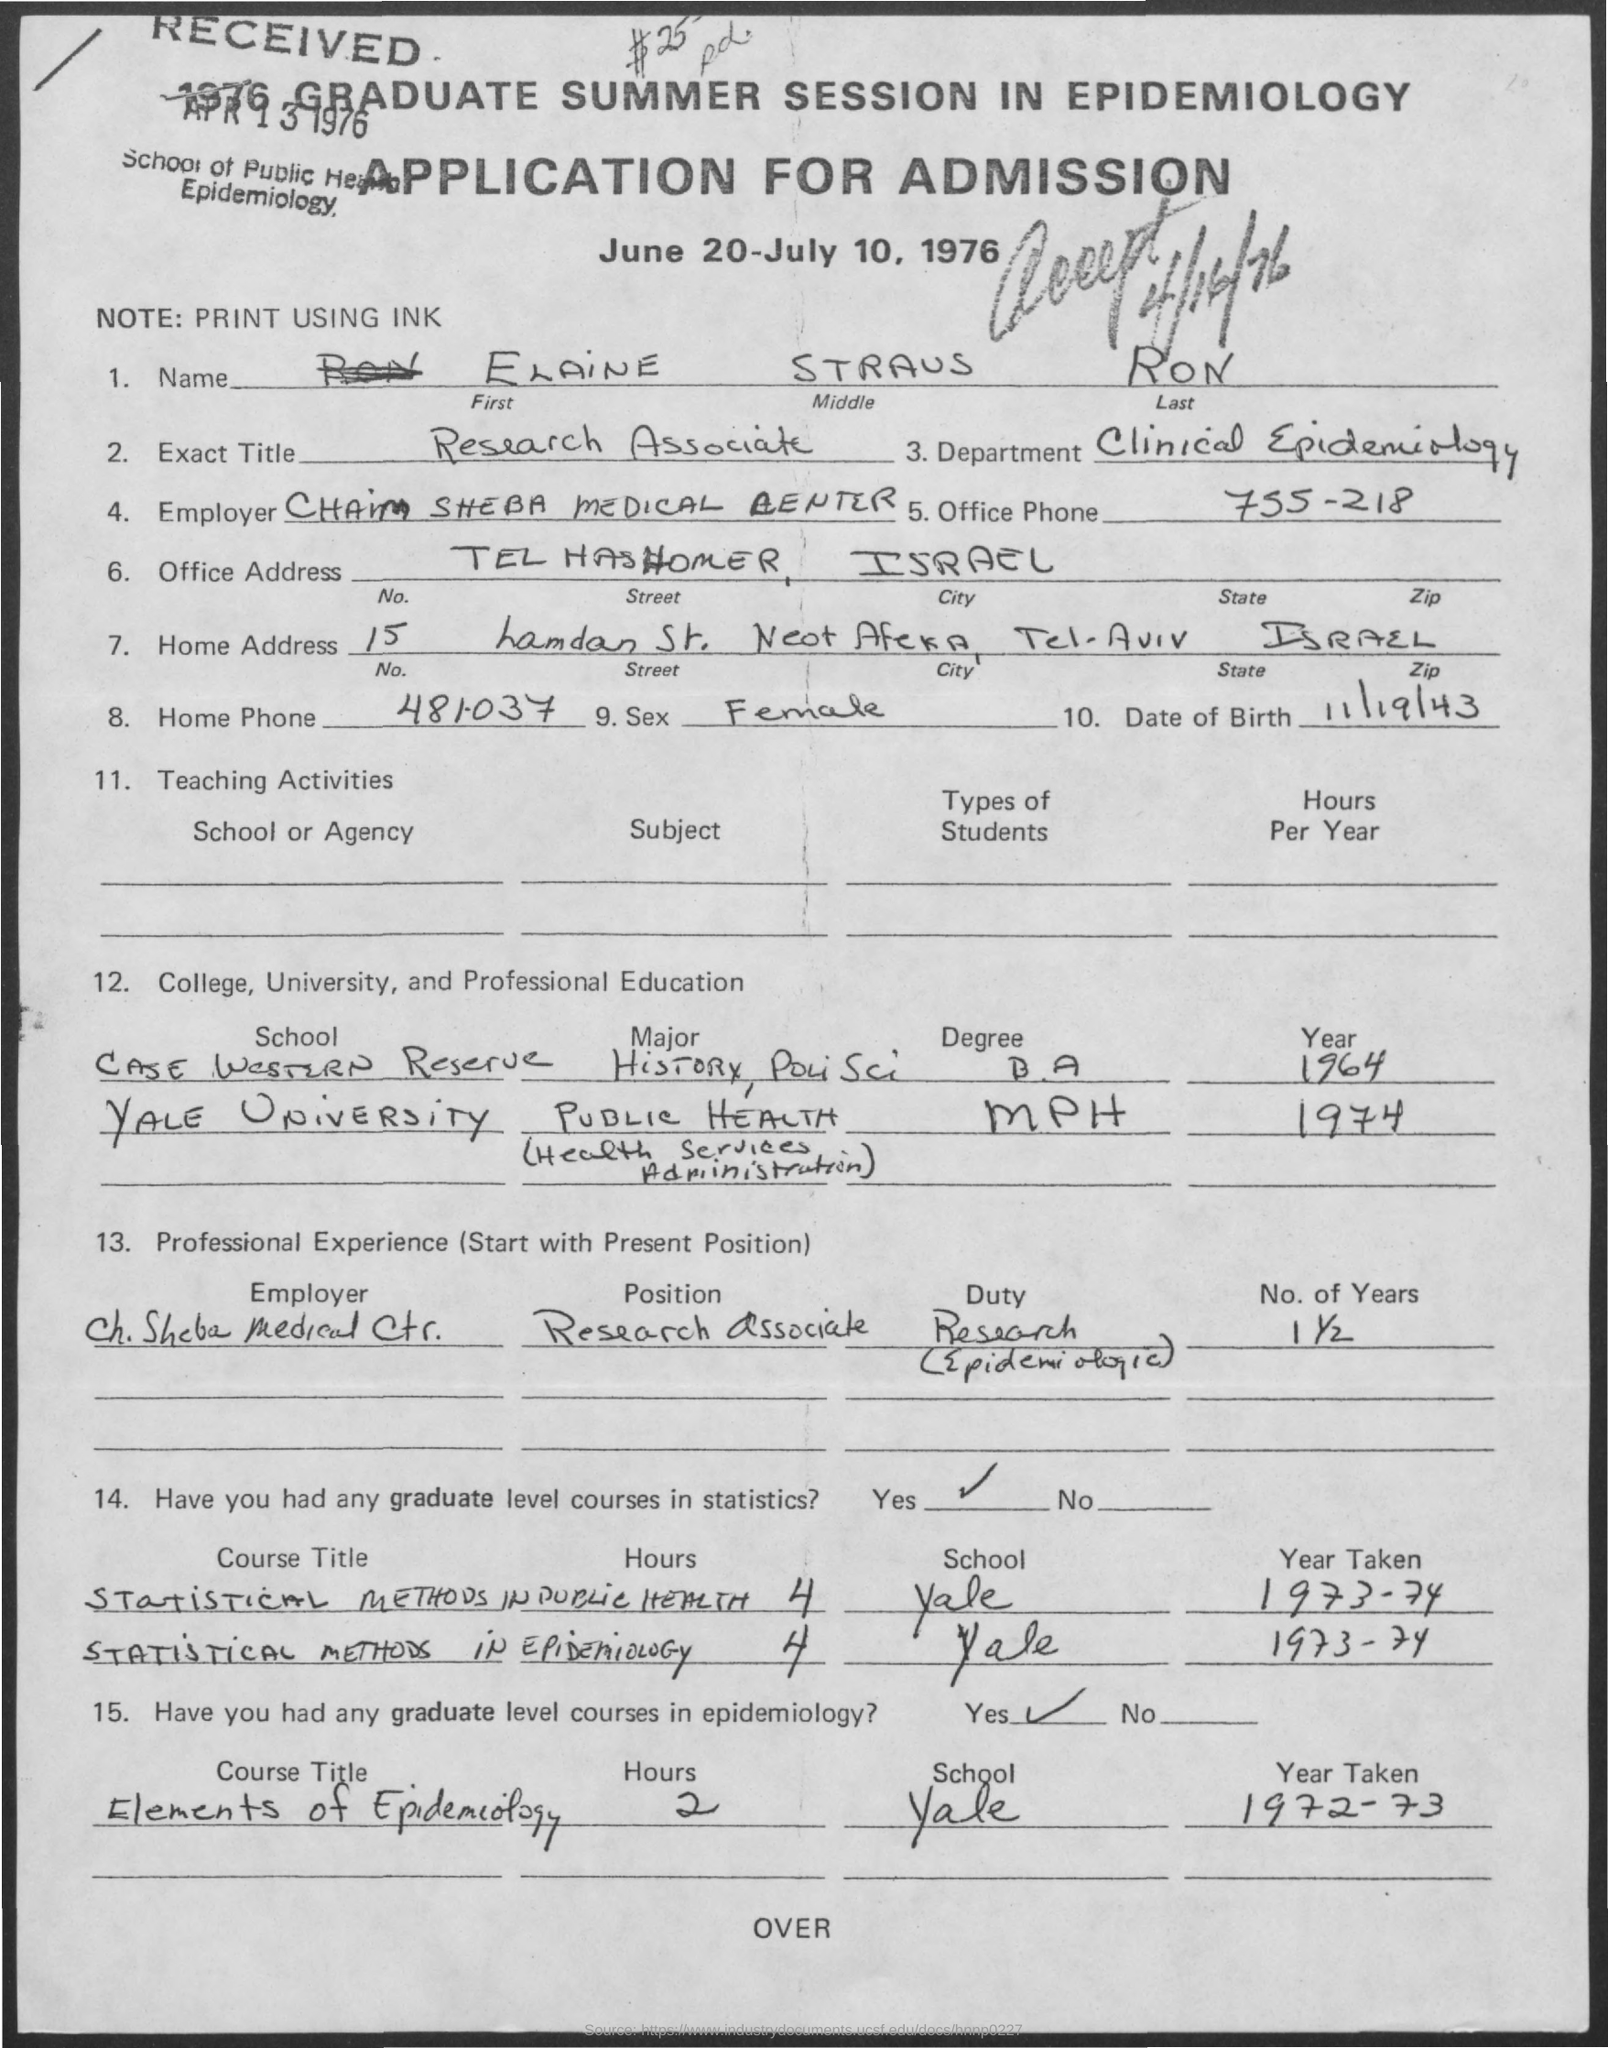List a handful of essential elements in this visual. The name given is Elaine Straus Ron. The course "Elements of Epidemiology" was taken by a student at Yale during the year 1972-1973. Elaine was a member of the Clinical Epidemiology department. 